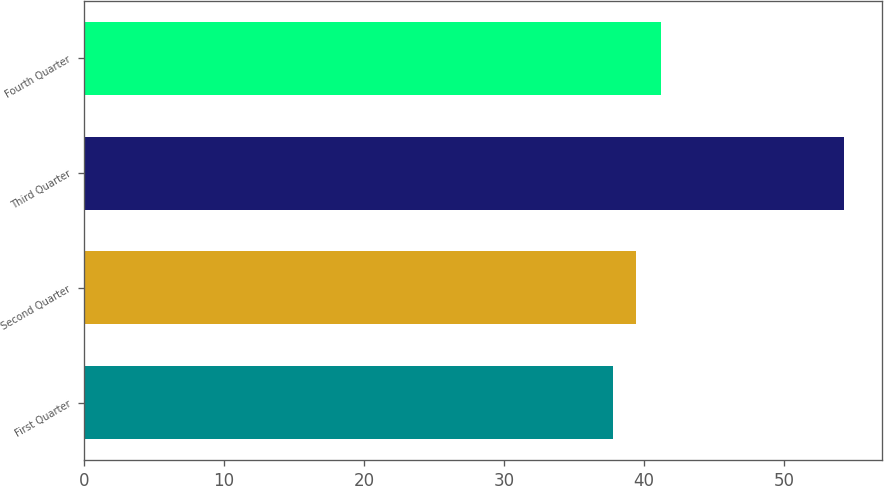Convert chart to OTSL. <chart><loc_0><loc_0><loc_500><loc_500><bar_chart><fcel>First Quarter<fcel>Second Quarter<fcel>Third Quarter<fcel>Fourth Quarter<nl><fcel>37.77<fcel>39.42<fcel>54.28<fcel>41.21<nl></chart> 